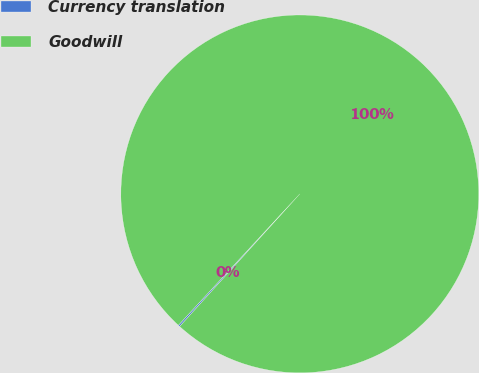Convert chart. <chart><loc_0><loc_0><loc_500><loc_500><pie_chart><fcel>Currency translation<fcel>Goodwill<nl><fcel>0.15%<fcel>99.85%<nl></chart> 